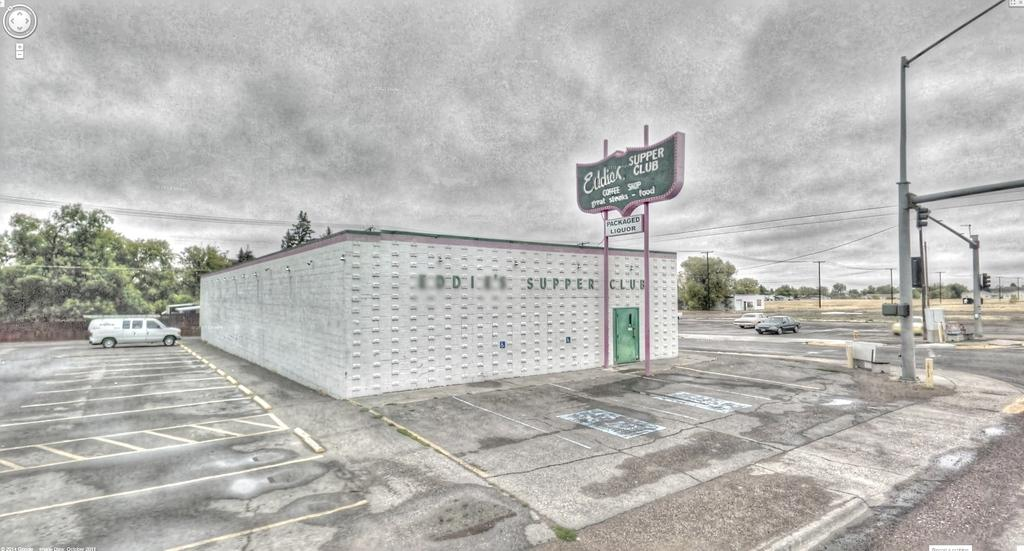What is the main structure in the middle of the image? There is a building in the middle of the image. What can be seen on the left side of the image? There is a vehicle on the left side of the image. Where is the vehicle located? The vehicle is on a road. What type of vegetation is present in the image? There are trees in the image. How would you describe the weather in the image? The sky is cloudy in the image. What type of noise does the dad make in the image? There is no dad present in the image, so it is not possible to determine what noise he might make. 